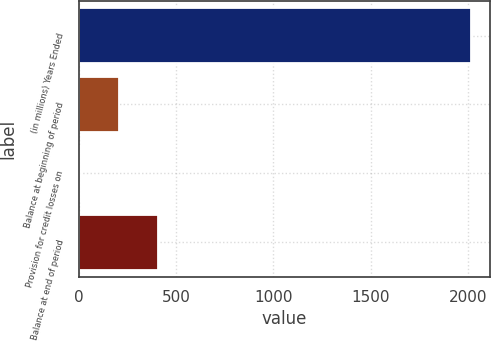Convert chart to OTSL. <chart><loc_0><loc_0><loc_500><loc_500><bar_chart><fcel>(in millions) Years Ended<fcel>Balance at beginning of period<fcel>Provision for credit losses on<fcel>Balance at end of period<nl><fcel>2012<fcel>206.6<fcel>6<fcel>407.2<nl></chart> 